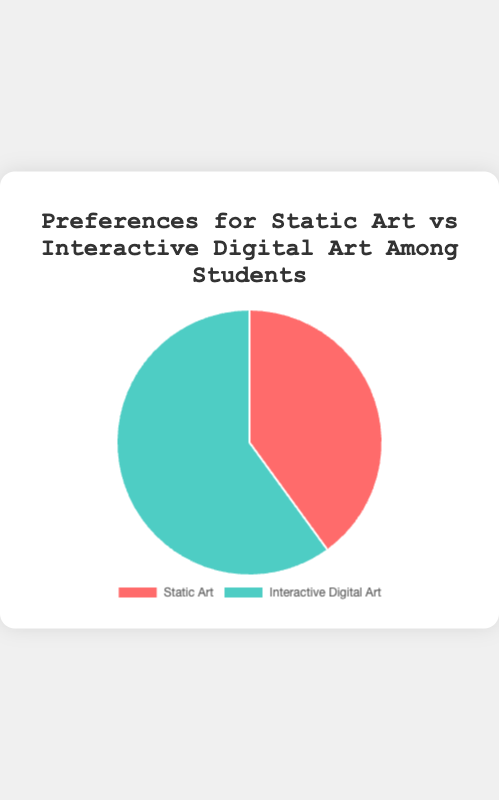What are the two categories of art preferences shown in the pie chart? The pie chart displays percentages for two categories of art preferences among students: Static Art and Interactive Digital Art.
Answer: Static Art and Interactive Digital Art Which type of art has a higher percentage of preference? Looking at the pie chart, the segment representing Interactive Digital Art is larger than the one for Static Art, indicating a higher percentage.
Answer: Interactive Digital Art By how much does the preference for Interactive Digital Art exceed Static Art? Interactive Digital Art has 60% and Static Art has 40%. The difference is calculated as 60% - 40%.
Answer: 20% What fraction of students prefer Static Art? The percentage of students who prefer Static Art is 40%. As a fraction, this is 40/100, which simplifies to 2/5.
Answer: 2/5 What is the ratio of students who prefer Interactive Digital Art to those who prefer Static Art? The percentage for Interactive Digital Art is 60% and for Static Art is 40%. The ratio of Interactive Digital Art to Static Art is 60:40, which simplifies to 3:2.
Answer: 3:2 Which segment of the pie chart is represented in red? Based on the chart's color scheme, the segment representing Static Art is red.
Answer: Static Art If you have a canvas showing the pie chart, can you explain which segment would be larger visually? The segment for Interactive Digital Art is visually larger as it represents 60% of the chart, compared to 40% for Static Art.
Answer: Interactive Digital Art What percentage of students prefer forms of art other than Interactive Digital Art? Since Interactive Digital Art represents 60%, the remaining percentage, representing forms of art other than Interactive Digital Art, is 100% - 60%.
Answer: 40% What combined percentage of students prefer both types of art? To find the combined percentage of students preferring both types of art, we add the percentages for Static Art and Interactive Digital Art: 40% + 60%.
Answer: 100% Which segment has a greenish color on the pie chart? The segment representing Interactive Digital Art has a greenish color.
Answer: Interactive Digital Art 